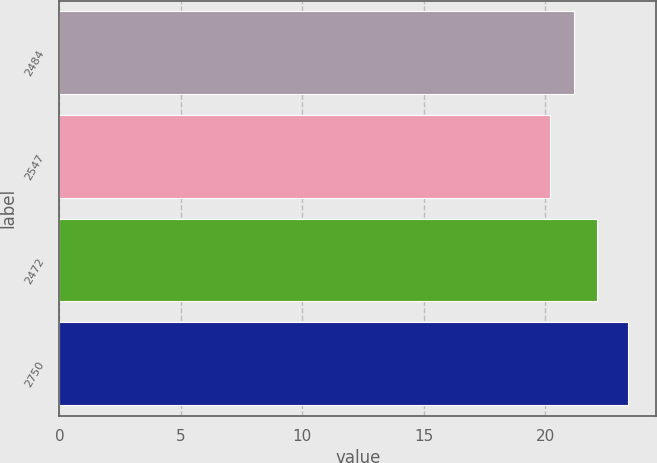Convert chart to OTSL. <chart><loc_0><loc_0><loc_500><loc_500><bar_chart><fcel>2484<fcel>2547<fcel>2472<fcel>2750<nl><fcel>21.17<fcel>20.21<fcel>22.13<fcel>23.4<nl></chart> 